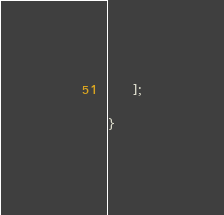Convert code to text. <code><loc_0><loc_0><loc_500><loc_500><_PHP_>

    ];

}</code> 